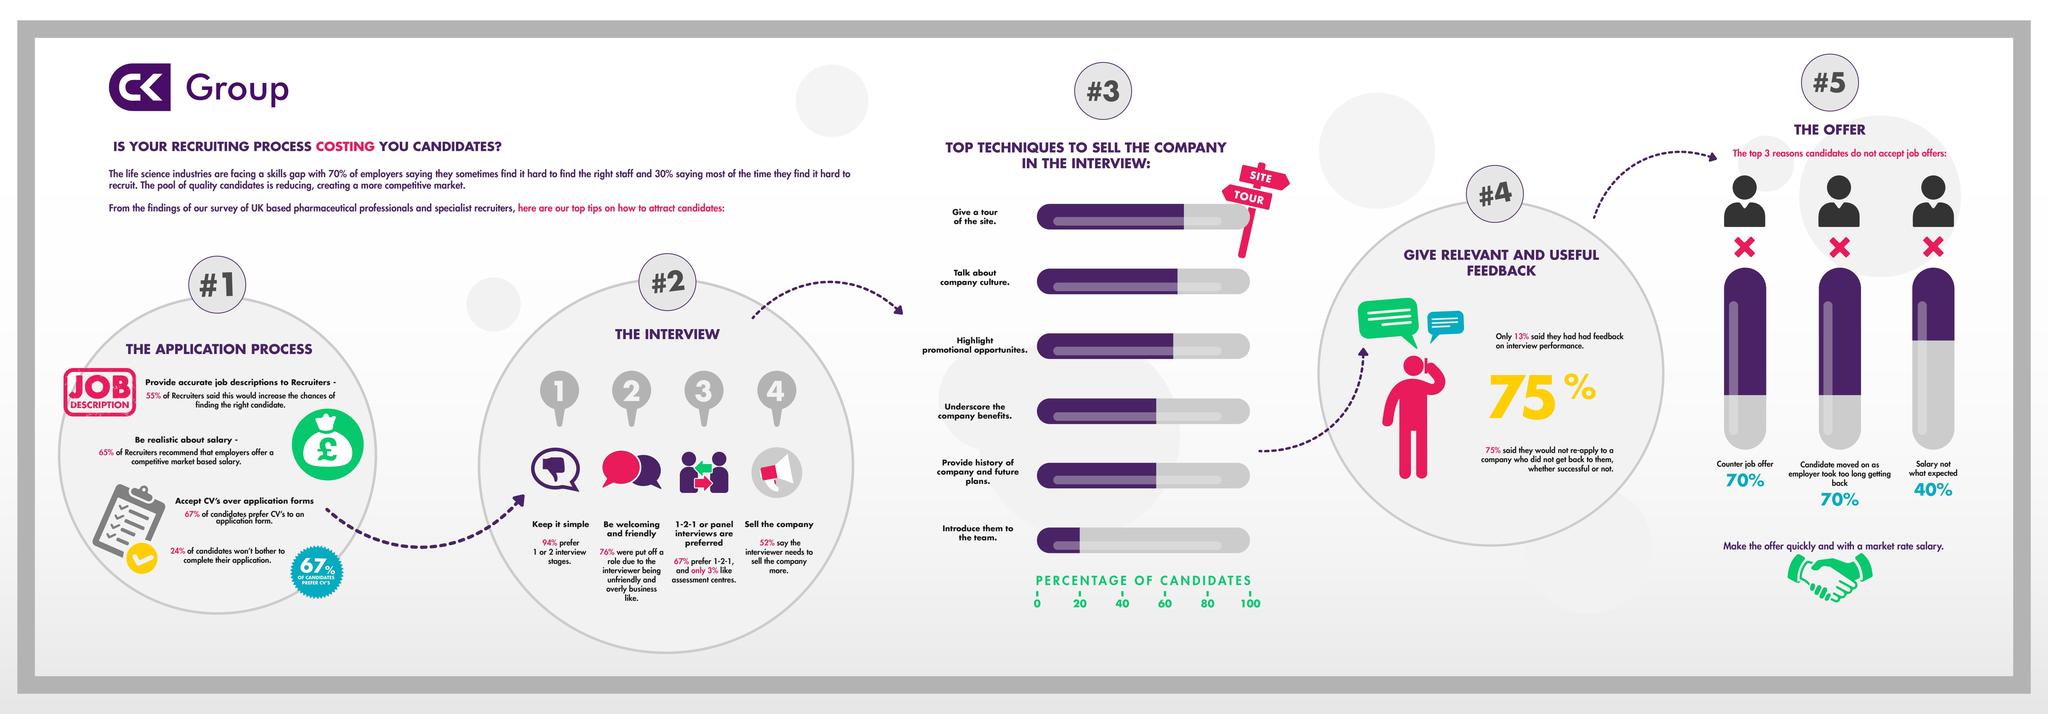What percentage of candidates prefer CV's to an application form?
Answer the question with a short phrase. 67% What is the top most technique to sell the company in the interview? give a tour of the site 